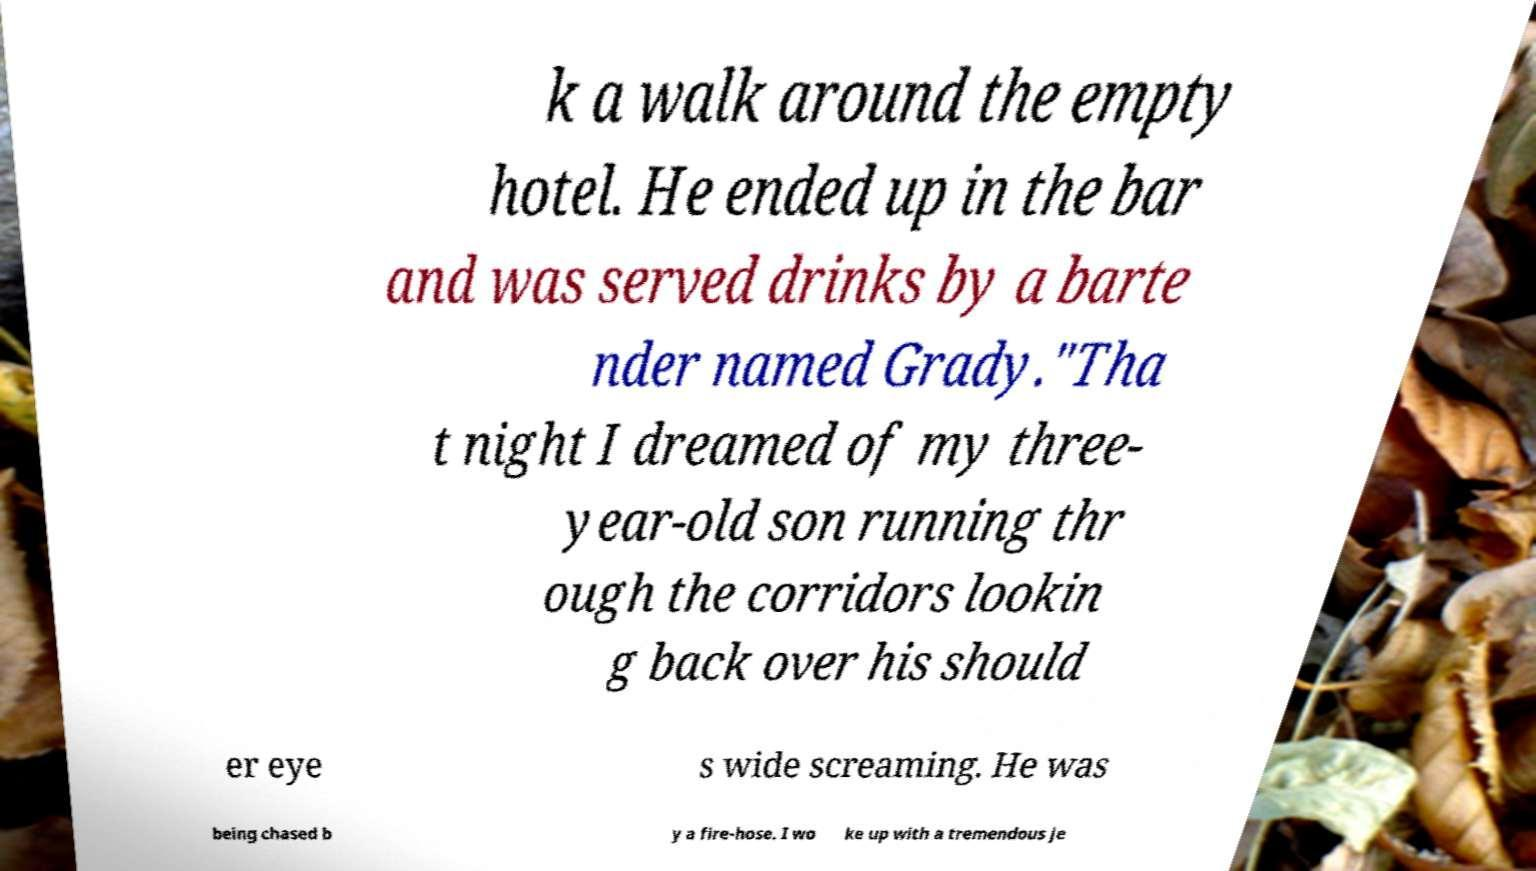What messages or text are displayed in this image? I need them in a readable, typed format. k a walk around the empty hotel. He ended up in the bar and was served drinks by a barte nder named Grady."Tha t night I dreamed of my three- year-old son running thr ough the corridors lookin g back over his should er eye s wide screaming. He was being chased b y a fire-hose. I wo ke up with a tremendous je 